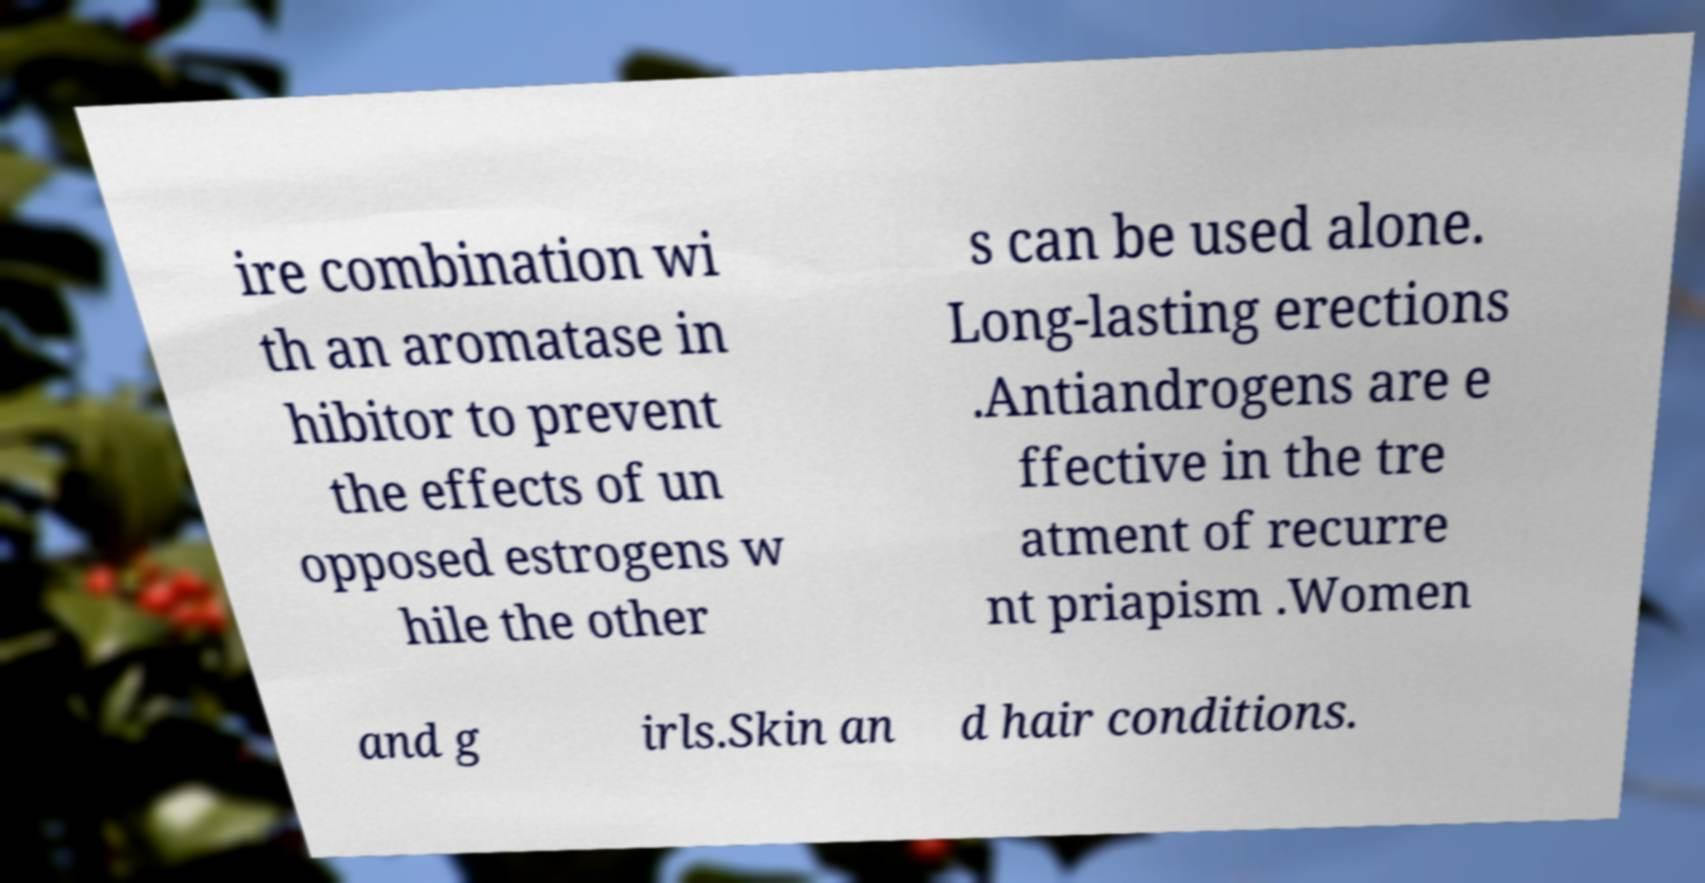Could you extract and type out the text from this image? ire combination wi th an aromatase in hibitor to prevent the effects of un opposed estrogens w hile the other s can be used alone. Long-lasting erections .Antiandrogens are e ffective in the tre atment of recurre nt priapism .Women and g irls.Skin an d hair conditions. 